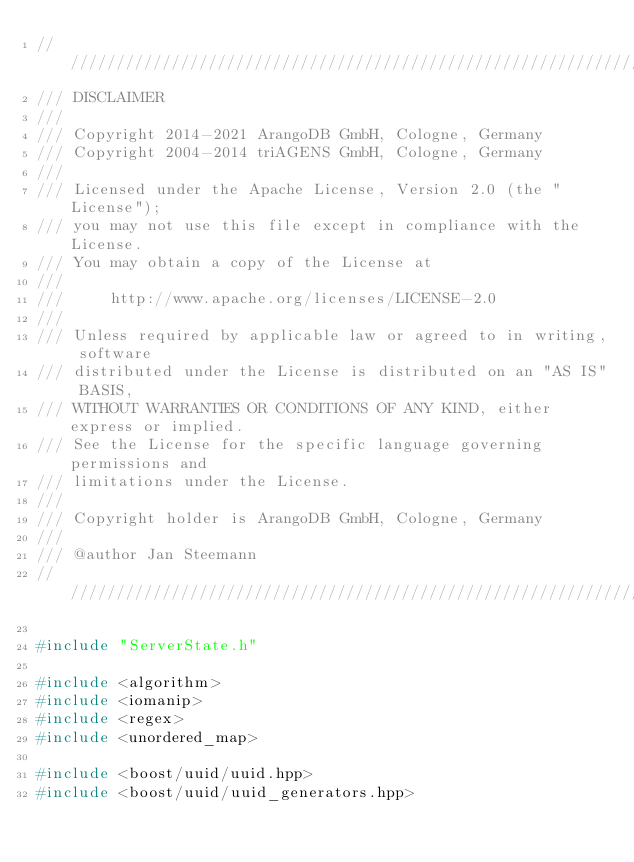<code> <loc_0><loc_0><loc_500><loc_500><_C++_>////////////////////////////////////////////////////////////////////////////////
/// DISCLAIMER
///
/// Copyright 2014-2021 ArangoDB GmbH, Cologne, Germany
/// Copyright 2004-2014 triAGENS GmbH, Cologne, Germany
///
/// Licensed under the Apache License, Version 2.0 (the "License");
/// you may not use this file except in compliance with the License.
/// You may obtain a copy of the License at
///
///     http://www.apache.org/licenses/LICENSE-2.0
///
/// Unless required by applicable law or agreed to in writing, software
/// distributed under the License is distributed on an "AS IS" BASIS,
/// WITHOUT WARRANTIES OR CONDITIONS OF ANY KIND, either express or implied.
/// See the License for the specific language governing permissions and
/// limitations under the License.
///
/// Copyright holder is ArangoDB GmbH, Cologne, Germany
///
/// @author Jan Steemann
////////////////////////////////////////////////////////////////////////////////

#include "ServerState.h"

#include <algorithm>
#include <iomanip>
#include <regex>
#include <unordered_map>

#include <boost/uuid/uuid.hpp>
#include <boost/uuid/uuid_generators.hpp></code> 